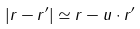<formula> <loc_0><loc_0><loc_500><loc_500>| { r - r ^ { \prime } } | \simeq r - { u \cdot r ^ { \prime } }</formula> 